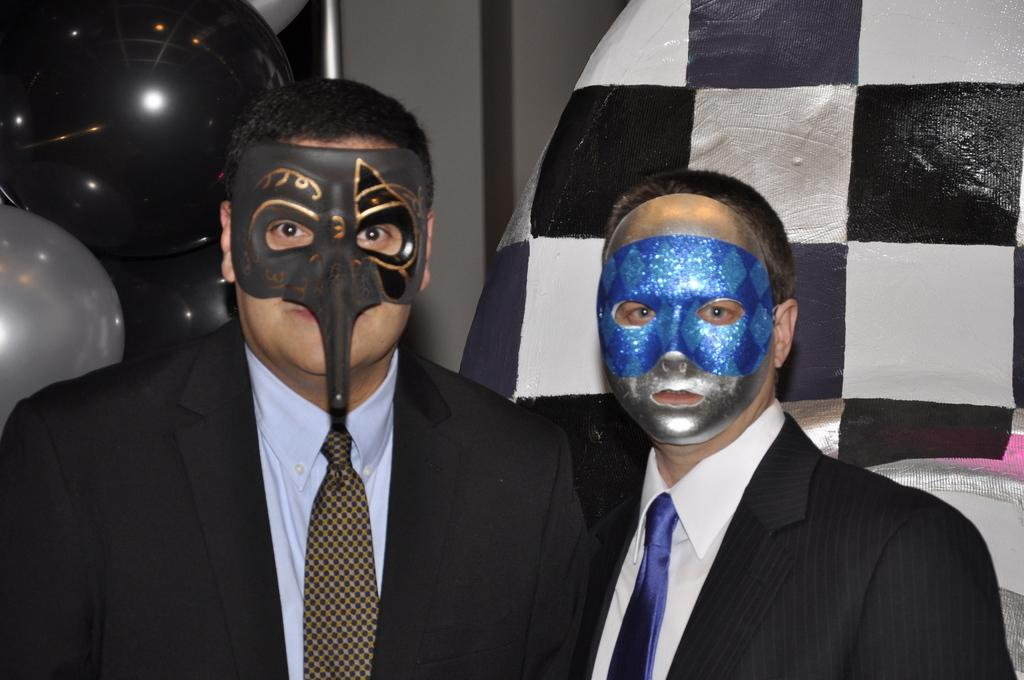How many people are in the image? There are two persons in the image. What are the persons wearing? The persons are wearing suits. What can be seen on the faces of the persons? The persons have masks on their faces. Can you describe any other objects or features in the background of the image? Unfortunately, the provided facts do not give any information about the background of the image. What type of word is being spelled out by the chickens in the image? There are no chickens present in the image, so it is not possible to answer that question. 